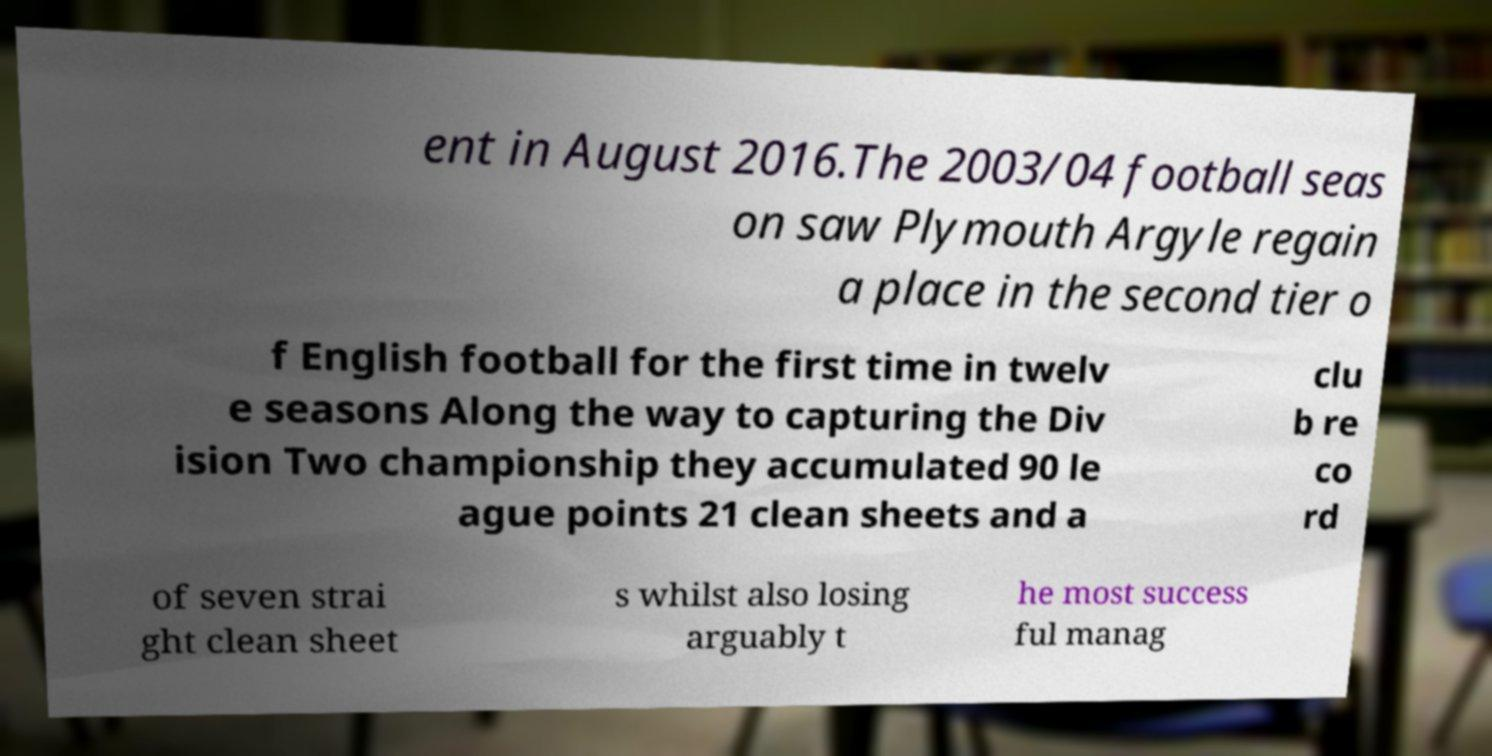Could you assist in decoding the text presented in this image and type it out clearly? ent in August 2016.The 2003/04 football seas on saw Plymouth Argyle regain a place in the second tier o f English football for the first time in twelv e seasons Along the way to capturing the Div ision Two championship they accumulated 90 le ague points 21 clean sheets and a clu b re co rd of seven strai ght clean sheet s whilst also losing arguably t he most success ful manag 